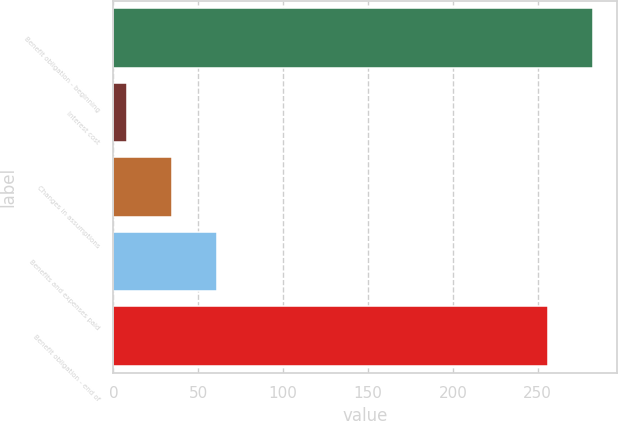Convert chart. <chart><loc_0><loc_0><loc_500><loc_500><bar_chart><fcel>Benefit obligation - beginning<fcel>Interest cost<fcel>Changes in assumptions<fcel>Benefits and expenses paid<fcel>Benefit obligation - end of<nl><fcel>282.4<fcel>8<fcel>34.4<fcel>60.8<fcel>256<nl></chart> 